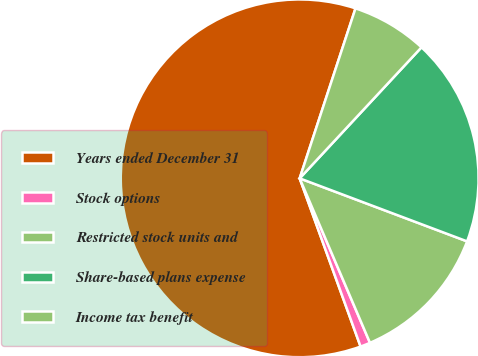Convert chart to OTSL. <chart><loc_0><loc_0><loc_500><loc_500><pie_chart><fcel>Years ended December 31<fcel>Stock options<fcel>Restricted stock units and<fcel>Share-based plans expense<fcel>Income tax benefit<nl><fcel>60.58%<fcel>0.9%<fcel>12.84%<fcel>18.81%<fcel>6.87%<nl></chart> 